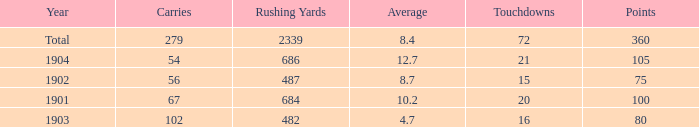What is the most number of touchdowns that have fewer than 105 points, averages over 4.7, and fewer than 487 rushing yards? None. 